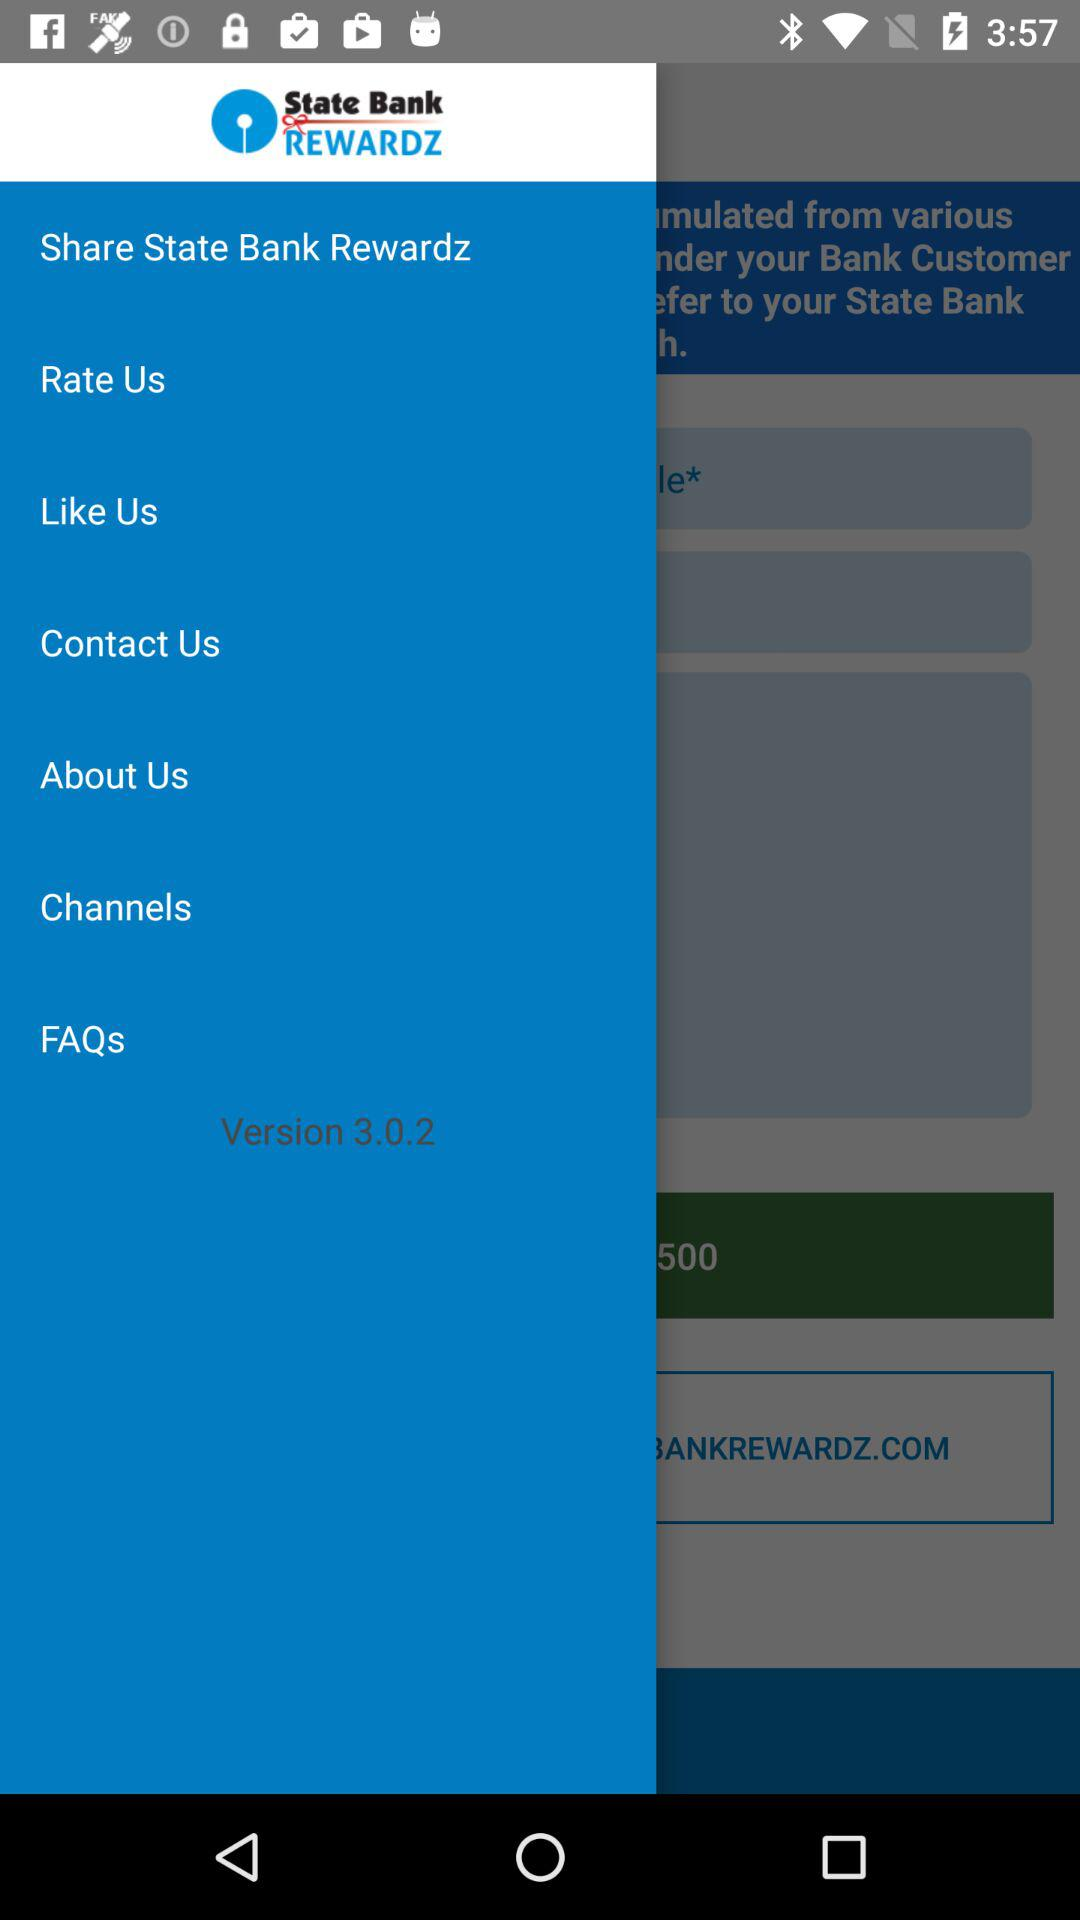What is the application name? The application name is "State Bank Rewards". 